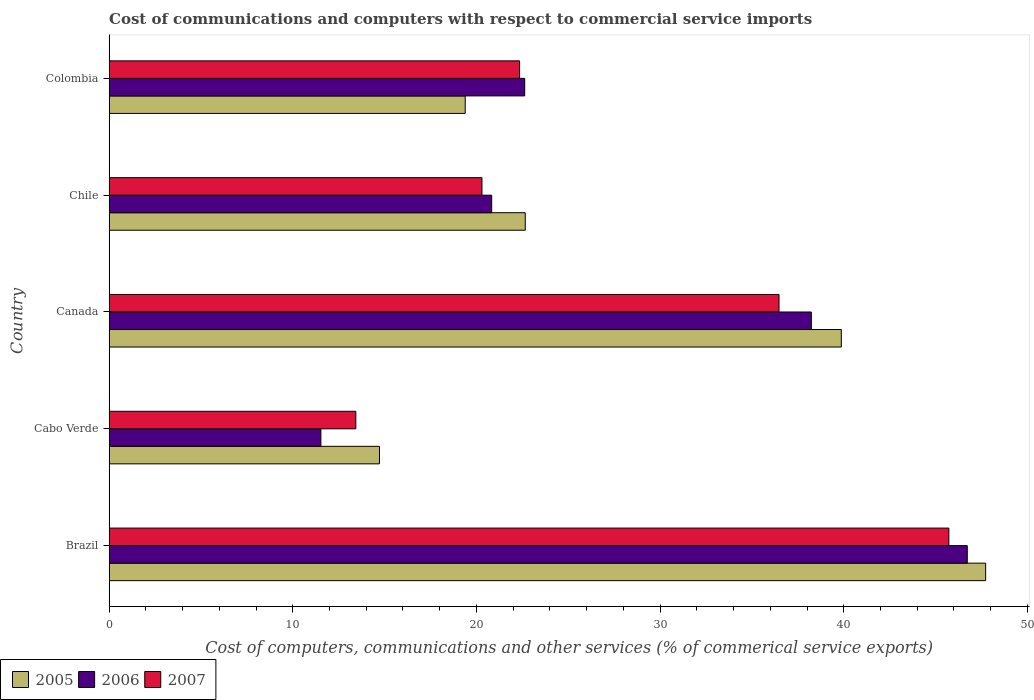How many groups of bars are there?
Provide a short and direct response. 5. Are the number of bars per tick equal to the number of legend labels?
Provide a short and direct response. Yes. How many bars are there on the 3rd tick from the bottom?
Your response must be concise. 3. What is the label of the 2nd group of bars from the top?
Offer a terse response. Chile. In how many cases, is the number of bars for a given country not equal to the number of legend labels?
Your answer should be very brief. 0. What is the cost of communications and computers in 2006 in Brazil?
Your answer should be compact. 46.73. Across all countries, what is the maximum cost of communications and computers in 2005?
Keep it short and to the point. 47.73. Across all countries, what is the minimum cost of communications and computers in 2007?
Offer a terse response. 13.44. In which country was the cost of communications and computers in 2007 minimum?
Your answer should be very brief. Cabo Verde. What is the total cost of communications and computers in 2006 in the graph?
Your answer should be very brief. 139.96. What is the difference between the cost of communications and computers in 2006 in Canada and that in Chile?
Offer a terse response. 17.4. What is the difference between the cost of communications and computers in 2006 in Canada and the cost of communications and computers in 2007 in Colombia?
Give a very brief answer. 15.88. What is the average cost of communications and computers in 2005 per country?
Keep it short and to the point. 28.87. What is the difference between the cost of communications and computers in 2006 and cost of communications and computers in 2005 in Cabo Verde?
Give a very brief answer. -3.19. What is the ratio of the cost of communications and computers in 2006 in Brazil to that in Chile?
Keep it short and to the point. 2.24. Is the cost of communications and computers in 2007 in Brazil less than that in Colombia?
Offer a very short reply. No. Is the difference between the cost of communications and computers in 2006 in Cabo Verde and Chile greater than the difference between the cost of communications and computers in 2005 in Cabo Verde and Chile?
Give a very brief answer. No. What is the difference between the highest and the second highest cost of communications and computers in 2007?
Ensure brevity in your answer.  9.25. What is the difference between the highest and the lowest cost of communications and computers in 2005?
Provide a succinct answer. 33.01. Is the sum of the cost of communications and computers in 2006 in Brazil and Cabo Verde greater than the maximum cost of communications and computers in 2007 across all countries?
Provide a succinct answer. Yes. What does the 2nd bar from the top in Canada represents?
Provide a succinct answer. 2006. What does the 3rd bar from the bottom in Chile represents?
Provide a succinct answer. 2007. How many bars are there?
Keep it short and to the point. 15. Are all the bars in the graph horizontal?
Offer a very short reply. Yes. How many countries are there in the graph?
Ensure brevity in your answer.  5. Where does the legend appear in the graph?
Keep it short and to the point. Bottom left. How many legend labels are there?
Your answer should be very brief. 3. How are the legend labels stacked?
Give a very brief answer. Horizontal. What is the title of the graph?
Your answer should be compact. Cost of communications and computers with respect to commercial service imports. Does "1973" appear as one of the legend labels in the graph?
Provide a short and direct response. No. What is the label or title of the X-axis?
Keep it short and to the point. Cost of computers, communications and other services (% of commerical service exports). What is the Cost of computers, communications and other services (% of commerical service exports) in 2005 in Brazil?
Provide a succinct answer. 47.73. What is the Cost of computers, communications and other services (% of commerical service exports) of 2006 in Brazil?
Give a very brief answer. 46.73. What is the Cost of computers, communications and other services (% of commerical service exports) of 2007 in Brazil?
Give a very brief answer. 45.72. What is the Cost of computers, communications and other services (% of commerical service exports) of 2005 in Cabo Verde?
Provide a succinct answer. 14.72. What is the Cost of computers, communications and other services (% of commerical service exports) of 2006 in Cabo Verde?
Keep it short and to the point. 11.53. What is the Cost of computers, communications and other services (% of commerical service exports) of 2007 in Cabo Verde?
Your answer should be compact. 13.44. What is the Cost of computers, communications and other services (% of commerical service exports) of 2005 in Canada?
Keep it short and to the point. 39.87. What is the Cost of computers, communications and other services (% of commerical service exports) of 2006 in Canada?
Give a very brief answer. 38.24. What is the Cost of computers, communications and other services (% of commerical service exports) of 2007 in Canada?
Give a very brief answer. 36.48. What is the Cost of computers, communications and other services (% of commerical service exports) of 2005 in Chile?
Ensure brevity in your answer.  22.66. What is the Cost of computers, communications and other services (% of commerical service exports) of 2006 in Chile?
Your answer should be compact. 20.83. What is the Cost of computers, communications and other services (% of commerical service exports) of 2007 in Chile?
Provide a succinct answer. 20.3. What is the Cost of computers, communications and other services (% of commerical service exports) in 2005 in Colombia?
Your response must be concise. 19.39. What is the Cost of computers, communications and other services (% of commerical service exports) in 2006 in Colombia?
Ensure brevity in your answer.  22.63. What is the Cost of computers, communications and other services (% of commerical service exports) of 2007 in Colombia?
Provide a short and direct response. 22.35. Across all countries, what is the maximum Cost of computers, communications and other services (% of commerical service exports) in 2005?
Your response must be concise. 47.73. Across all countries, what is the maximum Cost of computers, communications and other services (% of commerical service exports) in 2006?
Ensure brevity in your answer.  46.73. Across all countries, what is the maximum Cost of computers, communications and other services (% of commerical service exports) in 2007?
Your answer should be very brief. 45.72. Across all countries, what is the minimum Cost of computers, communications and other services (% of commerical service exports) of 2005?
Your answer should be compact. 14.72. Across all countries, what is the minimum Cost of computers, communications and other services (% of commerical service exports) in 2006?
Give a very brief answer. 11.53. Across all countries, what is the minimum Cost of computers, communications and other services (% of commerical service exports) of 2007?
Give a very brief answer. 13.44. What is the total Cost of computers, communications and other services (% of commerical service exports) of 2005 in the graph?
Provide a short and direct response. 144.37. What is the total Cost of computers, communications and other services (% of commerical service exports) in 2006 in the graph?
Your response must be concise. 139.96. What is the total Cost of computers, communications and other services (% of commerical service exports) in 2007 in the graph?
Give a very brief answer. 138.29. What is the difference between the Cost of computers, communications and other services (% of commerical service exports) of 2005 in Brazil and that in Cabo Verde?
Provide a succinct answer. 33.01. What is the difference between the Cost of computers, communications and other services (% of commerical service exports) of 2006 in Brazil and that in Cabo Verde?
Your answer should be compact. 35.19. What is the difference between the Cost of computers, communications and other services (% of commerical service exports) of 2007 in Brazil and that in Cabo Verde?
Ensure brevity in your answer.  32.29. What is the difference between the Cost of computers, communications and other services (% of commerical service exports) of 2005 in Brazil and that in Canada?
Offer a terse response. 7.86. What is the difference between the Cost of computers, communications and other services (% of commerical service exports) in 2006 in Brazil and that in Canada?
Your answer should be compact. 8.49. What is the difference between the Cost of computers, communications and other services (% of commerical service exports) of 2007 in Brazil and that in Canada?
Provide a succinct answer. 9.25. What is the difference between the Cost of computers, communications and other services (% of commerical service exports) of 2005 in Brazil and that in Chile?
Offer a terse response. 25.07. What is the difference between the Cost of computers, communications and other services (% of commerical service exports) in 2006 in Brazil and that in Chile?
Ensure brevity in your answer.  25.89. What is the difference between the Cost of computers, communications and other services (% of commerical service exports) in 2007 in Brazil and that in Chile?
Your answer should be compact. 25.42. What is the difference between the Cost of computers, communications and other services (% of commerical service exports) in 2005 in Brazil and that in Colombia?
Ensure brevity in your answer.  28.34. What is the difference between the Cost of computers, communications and other services (% of commerical service exports) of 2006 in Brazil and that in Colombia?
Your answer should be compact. 24.1. What is the difference between the Cost of computers, communications and other services (% of commerical service exports) in 2007 in Brazil and that in Colombia?
Your response must be concise. 23.37. What is the difference between the Cost of computers, communications and other services (% of commerical service exports) of 2005 in Cabo Verde and that in Canada?
Your answer should be compact. -25.15. What is the difference between the Cost of computers, communications and other services (% of commerical service exports) in 2006 in Cabo Verde and that in Canada?
Make the answer very short. -26.7. What is the difference between the Cost of computers, communications and other services (% of commerical service exports) in 2007 in Cabo Verde and that in Canada?
Ensure brevity in your answer.  -23.04. What is the difference between the Cost of computers, communications and other services (% of commerical service exports) in 2005 in Cabo Verde and that in Chile?
Give a very brief answer. -7.94. What is the difference between the Cost of computers, communications and other services (% of commerical service exports) in 2006 in Cabo Verde and that in Chile?
Make the answer very short. -9.3. What is the difference between the Cost of computers, communications and other services (% of commerical service exports) of 2007 in Cabo Verde and that in Chile?
Keep it short and to the point. -6.87. What is the difference between the Cost of computers, communications and other services (% of commerical service exports) in 2005 in Cabo Verde and that in Colombia?
Give a very brief answer. -4.67. What is the difference between the Cost of computers, communications and other services (% of commerical service exports) in 2006 in Cabo Verde and that in Colombia?
Provide a succinct answer. -11.1. What is the difference between the Cost of computers, communications and other services (% of commerical service exports) in 2007 in Cabo Verde and that in Colombia?
Your answer should be very brief. -8.92. What is the difference between the Cost of computers, communications and other services (% of commerical service exports) of 2005 in Canada and that in Chile?
Offer a very short reply. 17.21. What is the difference between the Cost of computers, communications and other services (% of commerical service exports) of 2006 in Canada and that in Chile?
Offer a terse response. 17.4. What is the difference between the Cost of computers, communications and other services (% of commerical service exports) in 2007 in Canada and that in Chile?
Ensure brevity in your answer.  16.17. What is the difference between the Cost of computers, communications and other services (% of commerical service exports) of 2005 in Canada and that in Colombia?
Offer a terse response. 20.48. What is the difference between the Cost of computers, communications and other services (% of commerical service exports) in 2006 in Canada and that in Colombia?
Give a very brief answer. 15.61. What is the difference between the Cost of computers, communications and other services (% of commerical service exports) in 2007 in Canada and that in Colombia?
Provide a short and direct response. 14.13. What is the difference between the Cost of computers, communications and other services (% of commerical service exports) of 2005 in Chile and that in Colombia?
Your answer should be compact. 3.27. What is the difference between the Cost of computers, communications and other services (% of commerical service exports) in 2006 in Chile and that in Colombia?
Provide a succinct answer. -1.8. What is the difference between the Cost of computers, communications and other services (% of commerical service exports) of 2007 in Chile and that in Colombia?
Offer a very short reply. -2.05. What is the difference between the Cost of computers, communications and other services (% of commerical service exports) in 2005 in Brazil and the Cost of computers, communications and other services (% of commerical service exports) in 2006 in Cabo Verde?
Your answer should be compact. 36.2. What is the difference between the Cost of computers, communications and other services (% of commerical service exports) in 2005 in Brazil and the Cost of computers, communications and other services (% of commerical service exports) in 2007 in Cabo Verde?
Provide a short and direct response. 34.29. What is the difference between the Cost of computers, communications and other services (% of commerical service exports) in 2006 in Brazil and the Cost of computers, communications and other services (% of commerical service exports) in 2007 in Cabo Verde?
Provide a short and direct response. 33.29. What is the difference between the Cost of computers, communications and other services (% of commerical service exports) of 2005 in Brazil and the Cost of computers, communications and other services (% of commerical service exports) of 2006 in Canada?
Ensure brevity in your answer.  9.49. What is the difference between the Cost of computers, communications and other services (% of commerical service exports) in 2005 in Brazil and the Cost of computers, communications and other services (% of commerical service exports) in 2007 in Canada?
Your answer should be compact. 11.25. What is the difference between the Cost of computers, communications and other services (% of commerical service exports) in 2006 in Brazil and the Cost of computers, communications and other services (% of commerical service exports) in 2007 in Canada?
Give a very brief answer. 10.25. What is the difference between the Cost of computers, communications and other services (% of commerical service exports) in 2005 in Brazil and the Cost of computers, communications and other services (% of commerical service exports) in 2006 in Chile?
Ensure brevity in your answer.  26.89. What is the difference between the Cost of computers, communications and other services (% of commerical service exports) of 2005 in Brazil and the Cost of computers, communications and other services (% of commerical service exports) of 2007 in Chile?
Your response must be concise. 27.43. What is the difference between the Cost of computers, communications and other services (% of commerical service exports) of 2006 in Brazil and the Cost of computers, communications and other services (% of commerical service exports) of 2007 in Chile?
Provide a short and direct response. 26.42. What is the difference between the Cost of computers, communications and other services (% of commerical service exports) of 2005 in Brazil and the Cost of computers, communications and other services (% of commerical service exports) of 2006 in Colombia?
Your answer should be very brief. 25.1. What is the difference between the Cost of computers, communications and other services (% of commerical service exports) of 2005 in Brazil and the Cost of computers, communications and other services (% of commerical service exports) of 2007 in Colombia?
Provide a short and direct response. 25.38. What is the difference between the Cost of computers, communications and other services (% of commerical service exports) in 2006 in Brazil and the Cost of computers, communications and other services (% of commerical service exports) in 2007 in Colombia?
Provide a succinct answer. 24.38. What is the difference between the Cost of computers, communications and other services (% of commerical service exports) of 2005 in Cabo Verde and the Cost of computers, communications and other services (% of commerical service exports) of 2006 in Canada?
Your response must be concise. -23.51. What is the difference between the Cost of computers, communications and other services (% of commerical service exports) of 2005 in Cabo Verde and the Cost of computers, communications and other services (% of commerical service exports) of 2007 in Canada?
Your response must be concise. -21.75. What is the difference between the Cost of computers, communications and other services (% of commerical service exports) in 2006 in Cabo Verde and the Cost of computers, communications and other services (% of commerical service exports) in 2007 in Canada?
Provide a succinct answer. -24.94. What is the difference between the Cost of computers, communications and other services (% of commerical service exports) in 2005 in Cabo Verde and the Cost of computers, communications and other services (% of commerical service exports) in 2006 in Chile?
Make the answer very short. -6.11. What is the difference between the Cost of computers, communications and other services (% of commerical service exports) of 2005 in Cabo Verde and the Cost of computers, communications and other services (% of commerical service exports) of 2007 in Chile?
Ensure brevity in your answer.  -5.58. What is the difference between the Cost of computers, communications and other services (% of commerical service exports) in 2006 in Cabo Verde and the Cost of computers, communications and other services (% of commerical service exports) in 2007 in Chile?
Make the answer very short. -8.77. What is the difference between the Cost of computers, communications and other services (% of commerical service exports) in 2005 in Cabo Verde and the Cost of computers, communications and other services (% of commerical service exports) in 2006 in Colombia?
Make the answer very short. -7.91. What is the difference between the Cost of computers, communications and other services (% of commerical service exports) in 2005 in Cabo Verde and the Cost of computers, communications and other services (% of commerical service exports) in 2007 in Colombia?
Give a very brief answer. -7.63. What is the difference between the Cost of computers, communications and other services (% of commerical service exports) in 2006 in Cabo Verde and the Cost of computers, communications and other services (% of commerical service exports) in 2007 in Colombia?
Ensure brevity in your answer.  -10.82. What is the difference between the Cost of computers, communications and other services (% of commerical service exports) in 2005 in Canada and the Cost of computers, communications and other services (% of commerical service exports) in 2006 in Chile?
Your answer should be very brief. 19.04. What is the difference between the Cost of computers, communications and other services (% of commerical service exports) in 2005 in Canada and the Cost of computers, communications and other services (% of commerical service exports) in 2007 in Chile?
Make the answer very short. 19.57. What is the difference between the Cost of computers, communications and other services (% of commerical service exports) in 2006 in Canada and the Cost of computers, communications and other services (% of commerical service exports) in 2007 in Chile?
Provide a short and direct response. 17.93. What is the difference between the Cost of computers, communications and other services (% of commerical service exports) in 2005 in Canada and the Cost of computers, communications and other services (% of commerical service exports) in 2006 in Colombia?
Make the answer very short. 17.24. What is the difference between the Cost of computers, communications and other services (% of commerical service exports) of 2005 in Canada and the Cost of computers, communications and other services (% of commerical service exports) of 2007 in Colombia?
Provide a succinct answer. 17.52. What is the difference between the Cost of computers, communications and other services (% of commerical service exports) of 2006 in Canada and the Cost of computers, communications and other services (% of commerical service exports) of 2007 in Colombia?
Offer a very short reply. 15.88. What is the difference between the Cost of computers, communications and other services (% of commerical service exports) in 2005 in Chile and the Cost of computers, communications and other services (% of commerical service exports) in 2006 in Colombia?
Your answer should be compact. 0.03. What is the difference between the Cost of computers, communications and other services (% of commerical service exports) in 2005 in Chile and the Cost of computers, communications and other services (% of commerical service exports) in 2007 in Colombia?
Provide a short and direct response. 0.31. What is the difference between the Cost of computers, communications and other services (% of commerical service exports) in 2006 in Chile and the Cost of computers, communications and other services (% of commerical service exports) in 2007 in Colombia?
Offer a terse response. -1.52. What is the average Cost of computers, communications and other services (% of commerical service exports) of 2005 per country?
Offer a very short reply. 28.87. What is the average Cost of computers, communications and other services (% of commerical service exports) in 2006 per country?
Provide a short and direct response. 27.99. What is the average Cost of computers, communications and other services (% of commerical service exports) in 2007 per country?
Make the answer very short. 27.66. What is the difference between the Cost of computers, communications and other services (% of commerical service exports) in 2005 and Cost of computers, communications and other services (% of commerical service exports) in 2007 in Brazil?
Your response must be concise. 2. What is the difference between the Cost of computers, communications and other services (% of commerical service exports) of 2005 and Cost of computers, communications and other services (% of commerical service exports) of 2006 in Cabo Verde?
Your response must be concise. 3.19. What is the difference between the Cost of computers, communications and other services (% of commerical service exports) in 2005 and Cost of computers, communications and other services (% of commerical service exports) in 2007 in Cabo Verde?
Ensure brevity in your answer.  1.29. What is the difference between the Cost of computers, communications and other services (% of commerical service exports) in 2006 and Cost of computers, communications and other services (% of commerical service exports) in 2007 in Cabo Verde?
Make the answer very short. -1.9. What is the difference between the Cost of computers, communications and other services (% of commerical service exports) in 2005 and Cost of computers, communications and other services (% of commerical service exports) in 2006 in Canada?
Provide a succinct answer. 1.63. What is the difference between the Cost of computers, communications and other services (% of commerical service exports) in 2005 and Cost of computers, communications and other services (% of commerical service exports) in 2007 in Canada?
Ensure brevity in your answer.  3.39. What is the difference between the Cost of computers, communications and other services (% of commerical service exports) of 2006 and Cost of computers, communications and other services (% of commerical service exports) of 2007 in Canada?
Make the answer very short. 1.76. What is the difference between the Cost of computers, communications and other services (% of commerical service exports) in 2005 and Cost of computers, communications and other services (% of commerical service exports) in 2006 in Chile?
Your response must be concise. 1.83. What is the difference between the Cost of computers, communications and other services (% of commerical service exports) of 2005 and Cost of computers, communications and other services (% of commerical service exports) of 2007 in Chile?
Make the answer very short. 2.36. What is the difference between the Cost of computers, communications and other services (% of commerical service exports) in 2006 and Cost of computers, communications and other services (% of commerical service exports) in 2007 in Chile?
Ensure brevity in your answer.  0.53. What is the difference between the Cost of computers, communications and other services (% of commerical service exports) of 2005 and Cost of computers, communications and other services (% of commerical service exports) of 2006 in Colombia?
Your answer should be compact. -3.24. What is the difference between the Cost of computers, communications and other services (% of commerical service exports) of 2005 and Cost of computers, communications and other services (% of commerical service exports) of 2007 in Colombia?
Offer a terse response. -2.96. What is the difference between the Cost of computers, communications and other services (% of commerical service exports) in 2006 and Cost of computers, communications and other services (% of commerical service exports) in 2007 in Colombia?
Your answer should be very brief. 0.28. What is the ratio of the Cost of computers, communications and other services (% of commerical service exports) in 2005 in Brazil to that in Cabo Verde?
Your answer should be compact. 3.24. What is the ratio of the Cost of computers, communications and other services (% of commerical service exports) in 2006 in Brazil to that in Cabo Verde?
Your answer should be very brief. 4.05. What is the ratio of the Cost of computers, communications and other services (% of commerical service exports) of 2007 in Brazil to that in Cabo Verde?
Provide a succinct answer. 3.4. What is the ratio of the Cost of computers, communications and other services (% of commerical service exports) of 2005 in Brazil to that in Canada?
Your response must be concise. 1.2. What is the ratio of the Cost of computers, communications and other services (% of commerical service exports) in 2006 in Brazil to that in Canada?
Offer a very short reply. 1.22. What is the ratio of the Cost of computers, communications and other services (% of commerical service exports) in 2007 in Brazil to that in Canada?
Your response must be concise. 1.25. What is the ratio of the Cost of computers, communications and other services (% of commerical service exports) in 2005 in Brazil to that in Chile?
Ensure brevity in your answer.  2.11. What is the ratio of the Cost of computers, communications and other services (% of commerical service exports) in 2006 in Brazil to that in Chile?
Your answer should be very brief. 2.24. What is the ratio of the Cost of computers, communications and other services (% of commerical service exports) of 2007 in Brazil to that in Chile?
Provide a succinct answer. 2.25. What is the ratio of the Cost of computers, communications and other services (% of commerical service exports) in 2005 in Brazil to that in Colombia?
Give a very brief answer. 2.46. What is the ratio of the Cost of computers, communications and other services (% of commerical service exports) in 2006 in Brazil to that in Colombia?
Your response must be concise. 2.06. What is the ratio of the Cost of computers, communications and other services (% of commerical service exports) of 2007 in Brazil to that in Colombia?
Your response must be concise. 2.05. What is the ratio of the Cost of computers, communications and other services (% of commerical service exports) in 2005 in Cabo Verde to that in Canada?
Make the answer very short. 0.37. What is the ratio of the Cost of computers, communications and other services (% of commerical service exports) in 2006 in Cabo Verde to that in Canada?
Provide a succinct answer. 0.3. What is the ratio of the Cost of computers, communications and other services (% of commerical service exports) of 2007 in Cabo Verde to that in Canada?
Offer a terse response. 0.37. What is the ratio of the Cost of computers, communications and other services (% of commerical service exports) of 2005 in Cabo Verde to that in Chile?
Give a very brief answer. 0.65. What is the ratio of the Cost of computers, communications and other services (% of commerical service exports) of 2006 in Cabo Verde to that in Chile?
Your answer should be very brief. 0.55. What is the ratio of the Cost of computers, communications and other services (% of commerical service exports) in 2007 in Cabo Verde to that in Chile?
Provide a short and direct response. 0.66. What is the ratio of the Cost of computers, communications and other services (% of commerical service exports) in 2005 in Cabo Verde to that in Colombia?
Keep it short and to the point. 0.76. What is the ratio of the Cost of computers, communications and other services (% of commerical service exports) in 2006 in Cabo Verde to that in Colombia?
Offer a terse response. 0.51. What is the ratio of the Cost of computers, communications and other services (% of commerical service exports) of 2007 in Cabo Verde to that in Colombia?
Offer a terse response. 0.6. What is the ratio of the Cost of computers, communications and other services (% of commerical service exports) of 2005 in Canada to that in Chile?
Offer a terse response. 1.76. What is the ratio of the Cost of computers, communications and other services (% of commerical service exports) in 2006 in Canada to that in Chile?
Make the answer very short. 1.84. What is the ratio of the Cost of computers, communications and other services (% of commerical service exports) in 2007 in Canada to that in Chile?
Ensure brevity in your answer.  1.8. What is the ratio of the Cost of computers, communications and other services (% of commerical service exports) in 2005 in Canada to that in Colombia?
Provide a succinct answer. 2.06. What is the ratio of the Cost of computers, communications and other services (% of commerical service exports) in 2006 in Canada to that in Colombia?
Provide a succinct answer. 1.69. What is the ratio of the Cost of computers, communications and other services (% of commerical service exports) of 2007 in Canada to that in Colombia?
Ensure brevity in your answer.  1.63. What is the ratio of the Cost of computers, communications and other services (% of commerical service exports) of 2005 in Chile to that in Colombia?
Offer a very short reply. 1.17. What is the ratio of the Cost of computers, communications and other services (% of commerical service exports) of 2006 in Chile to that in Colombia?
Your answer should be very brief. 0.92. What is the ratio of the Cost of computers, communications and other services (% of commerical service exports) of 2007 in Chile to that in Colombia?
Your response must be concise. 0.91. What is the difference between the highest and the second highest Cost of computers, communications and other services (% of commerical service exports) of 2005?
Keep it short and to the point. 7.86. What is the difference between the highest and the second highest Cost of computers, communications and other services (% of commerical service exports) in 2006?
Offer a very short reply. 8.49. What is the difference between the highest and the second highest Cost of computers, communications and other services (% of commerical service exports) of 2007?
Keep it short and to the point. 9.25. What is the difference between the highest and the lowest Cost of computers, communications and other services (% of commerical service exports) in 2005?
Make the answer very short. 33.01. What is the difference between the highest and the lowest Cost of computers, communications and other services (% of commerical service exports) in 2006?
Offer a very short reply. 35.19. What is the difference between the highest and the lowest Cost of computers, communications and other services (% of commerical service exports) of 2007?
Provide a succinct answer. 32.29. 